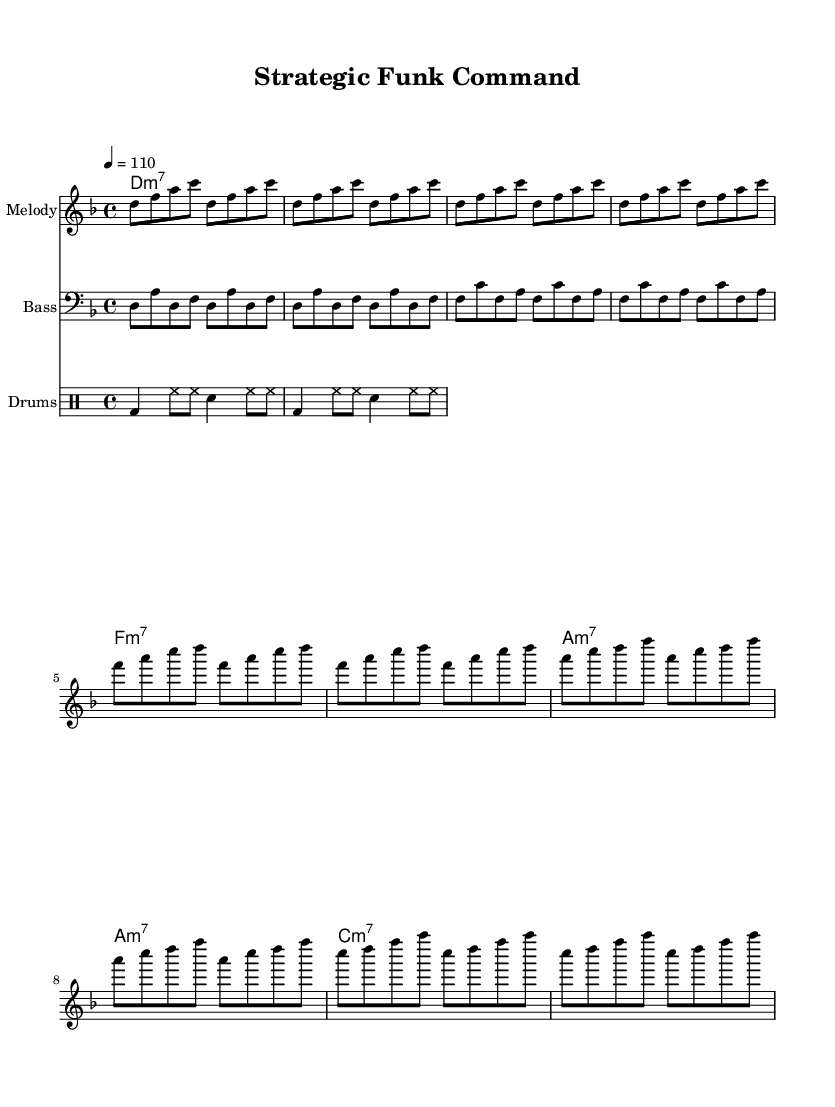What is the key signature of this music? The key signature is D minor, which comprises one flat (B flat). This can be identified at the beginning of the staff where the key signature is indicated.
Answer: D minor What is the time signature of this music? The time signature is 4/4, indicated at the beginning of the score. It shows that there are four beats in each measure and a quarter note receives one beat.
Answer: 4/4 What is the tempo marking for this piece? The tempo marking is 4 equals 110, which signifies that each quarter note is played at a speed of 110 beats per minute. This is noted near the beginning of the piece under the tempo directive.
Answer: 110 How many measures are in the chorus section? The chorus section consists of four measures. This can be determined by locating the chorus section within the score and counting the groups between the bar lines.
Answer: 4 What is the main chord used in the intro? The main chord used in the intro is D minor 7. This can be observed in the chord symbols above the staff in the intro section of the sheet music.
Answer: D minor 7 What rhythmic pattern is used in the bass line? The bass line follows a pattern of eighth notes and quarter notes, creating a syncopated groove typical of funk music. This is evident when analyzing the rhythmic values in the bass staff.
Answer: Eighth and quarter notes 